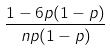<formula> <loc_0><loc_0><loc_500><loc_500>\frac { 1 - 6 p ( 1 - p ) } { n p ( 1 - p ) }</formula> 